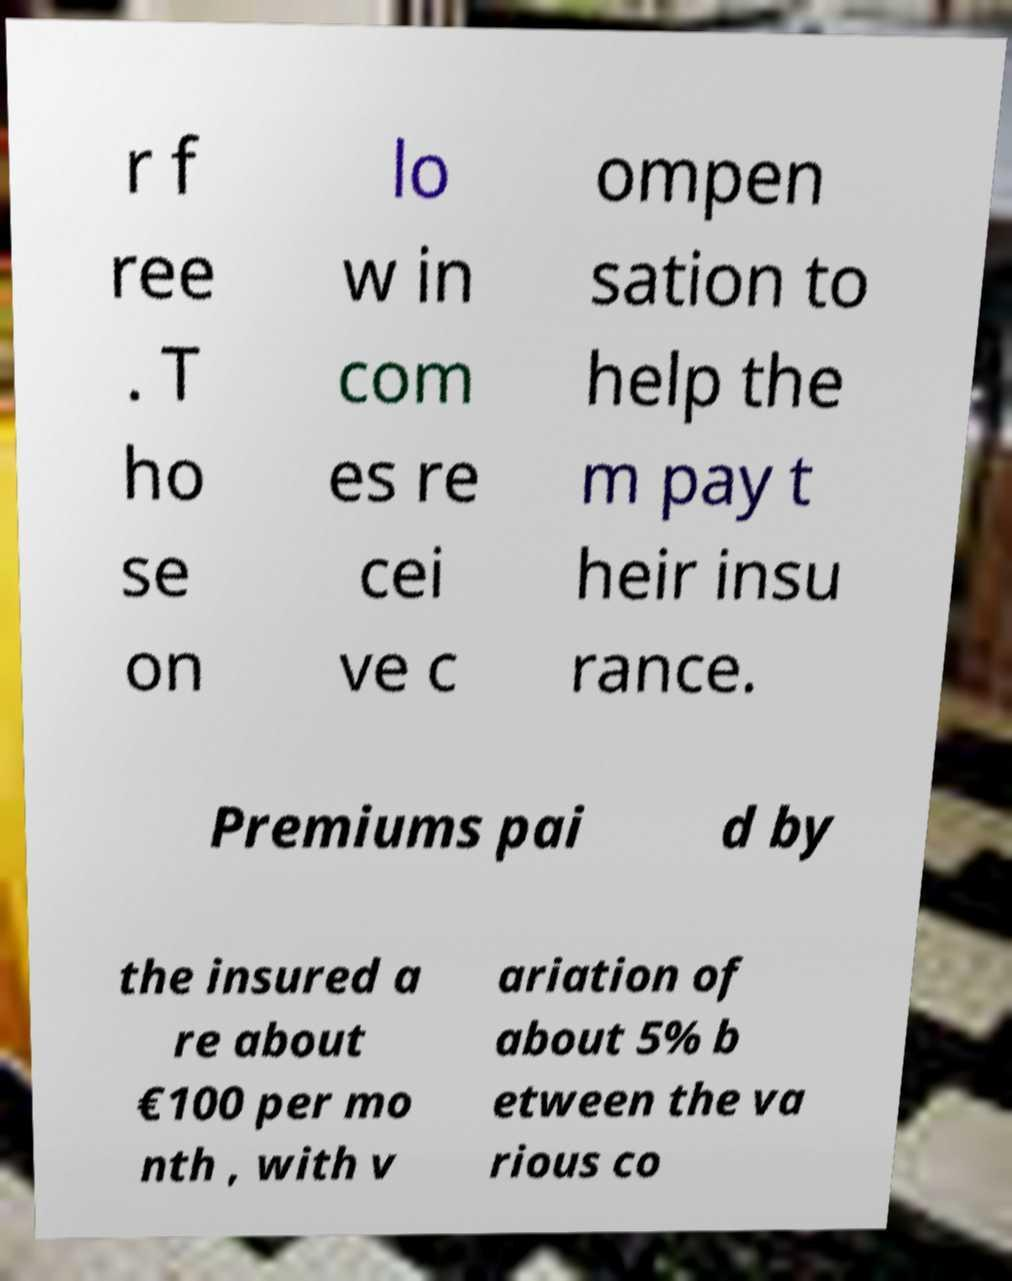Could you assist in decoding the text presented in this image and type it out clearly? r f ree . T ho se on lo w in com es re cei ve c ompen sation to help the m pay t heir insu rance. Premiums pai d by the insured a re about €100 per mo nth , with v ariation of about 5% b etween the va rious co 